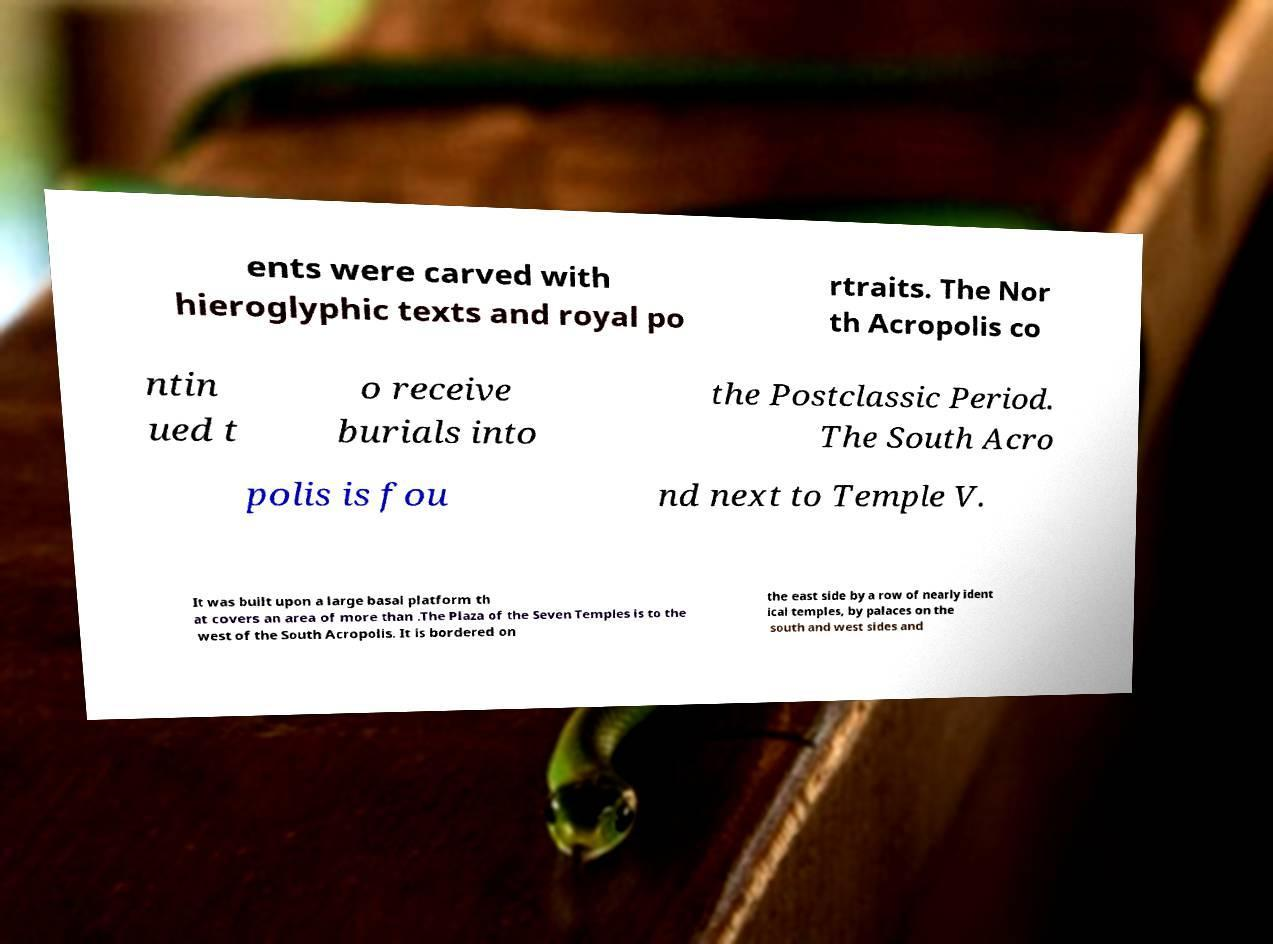What messages or text are displayed in this image? I need them in a readable, typed format. ents were carved with hieroglyphic texts and royal po rtraits. The Nor th Acropolis co ntin ued t o receive burials into the Postclassic Period. The South Acro polis is fou nd next to Temple V. It was built upon a large basal platform th at covers an area of more than .The Plaza of the Seven Temples is to the west of the South Acropolis. It is bordered on the east side by a row of nearly ident ical temples, by palaces on the south and west sides and 